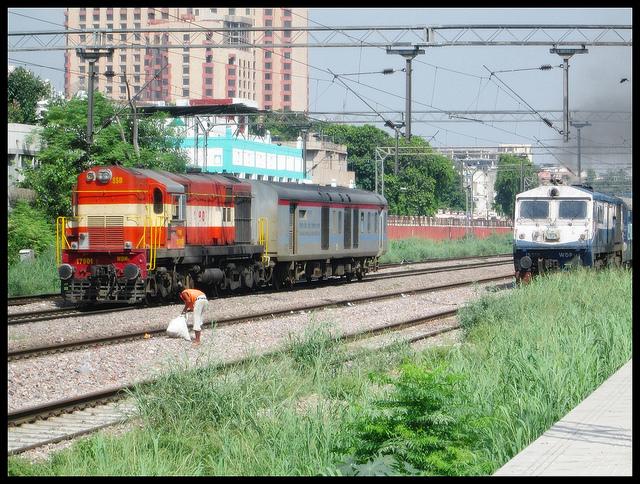Is the train moving?
Concise answer only. Yes. Is this a country landscape?
Short answer required. No. Is there someone picking up trash?
Concise answer only. Yes. What sort of transportation system is present?
Write a very short answer. Train. What accessory is the person near the pole wearing?
Keep it brief. Belt. Is this a commuter train?
Short answer required. No. What's the name of this train?
Write a very short answer. Train. Are these tracks frequently used?
Concise answer only. Yes. What train car has been left behind here?
Answer briefly. None. 